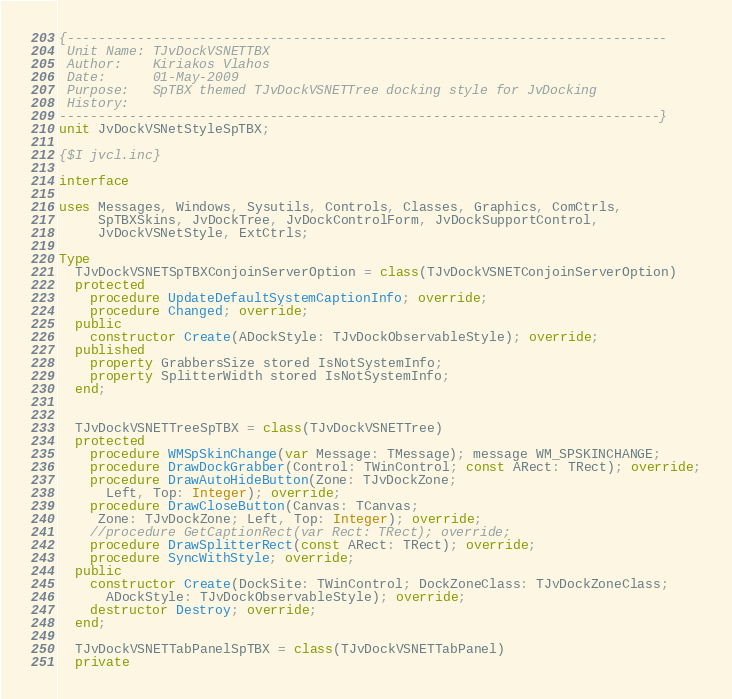Convert code to text. <code><loc_0><loc_0><loc_500><loc_500><_Pascal_>{-----------------------------------------------------------------------------
 Unit Name: TJvDockVSNETTBX
 Author:    Kiriakos Vlahos
 Date:      01-May-2009
 Purpose:   SpTBX themed TJvDockVSNETTree docking style for JvDocking
 History:
-----------------------------------------------------------------------------}
unit JvDockVSNetStyleSpTBX;

{$I jvcl.inc}

interface

uses Messages, Windows, Sysutils, Controls, Classes, Graphics, ComCtrls,
     SpTBXSkins, JvDockTree, JvDockControlForm, JvDockSupportControl,
     JvDockVSNetStyle, ExtCtrls;

Type
  TJvDockVSNETSpTBXConjoinServerOption = class(TJvDockVSNETConjoinServerOption)
  protected
    procedure UpdateDefaultSystemCaptionInfo; override;
    procedure Changed; override;
  public
    constructor Create(ADockStyle: TJvDockObservableStyle); override;
  published
    property GrabbersSize stored IsNotSystemInfo;
    property SplitterWidth stored IsNotSystemInfo;
  end;


  TJvDockVSNETTreeSpTBX = class(TJvDockVSNETTree)
  protected
    procedure WMSpSkinChange(var Message: TMessage); message WM_SPSKINCHANGE;
    procedure DrawDockGrabber(Control: TWinControl; const ARect: TRect); override;
    procedure DrawAutoHideButton(Zone: TJvDockZone;
      Left, Top: Integer); override;
    procedure DrawCloseButton(Canvas: TCanvas;
     Zone: TJvDockZone; Left, Top: Integer); override;
    //procedure GetCaptionRect(var Rect: TRect); override;
    procedure DrawSplitterRect(const ARect: TRect); override;
    procedure SyncWithStyle; override;
  public
    constructor Create(DockSite: TWinControl; DockZoneClass: TJvDockZoneClass;
      ADockStyle: TJvDockObservableStyle); override;
    destructor Destroy; override;
  end;

  TJvDockVSNETTabPanelSpTBX = class(TJvDockVSNETTabPanel)
  private</code> 